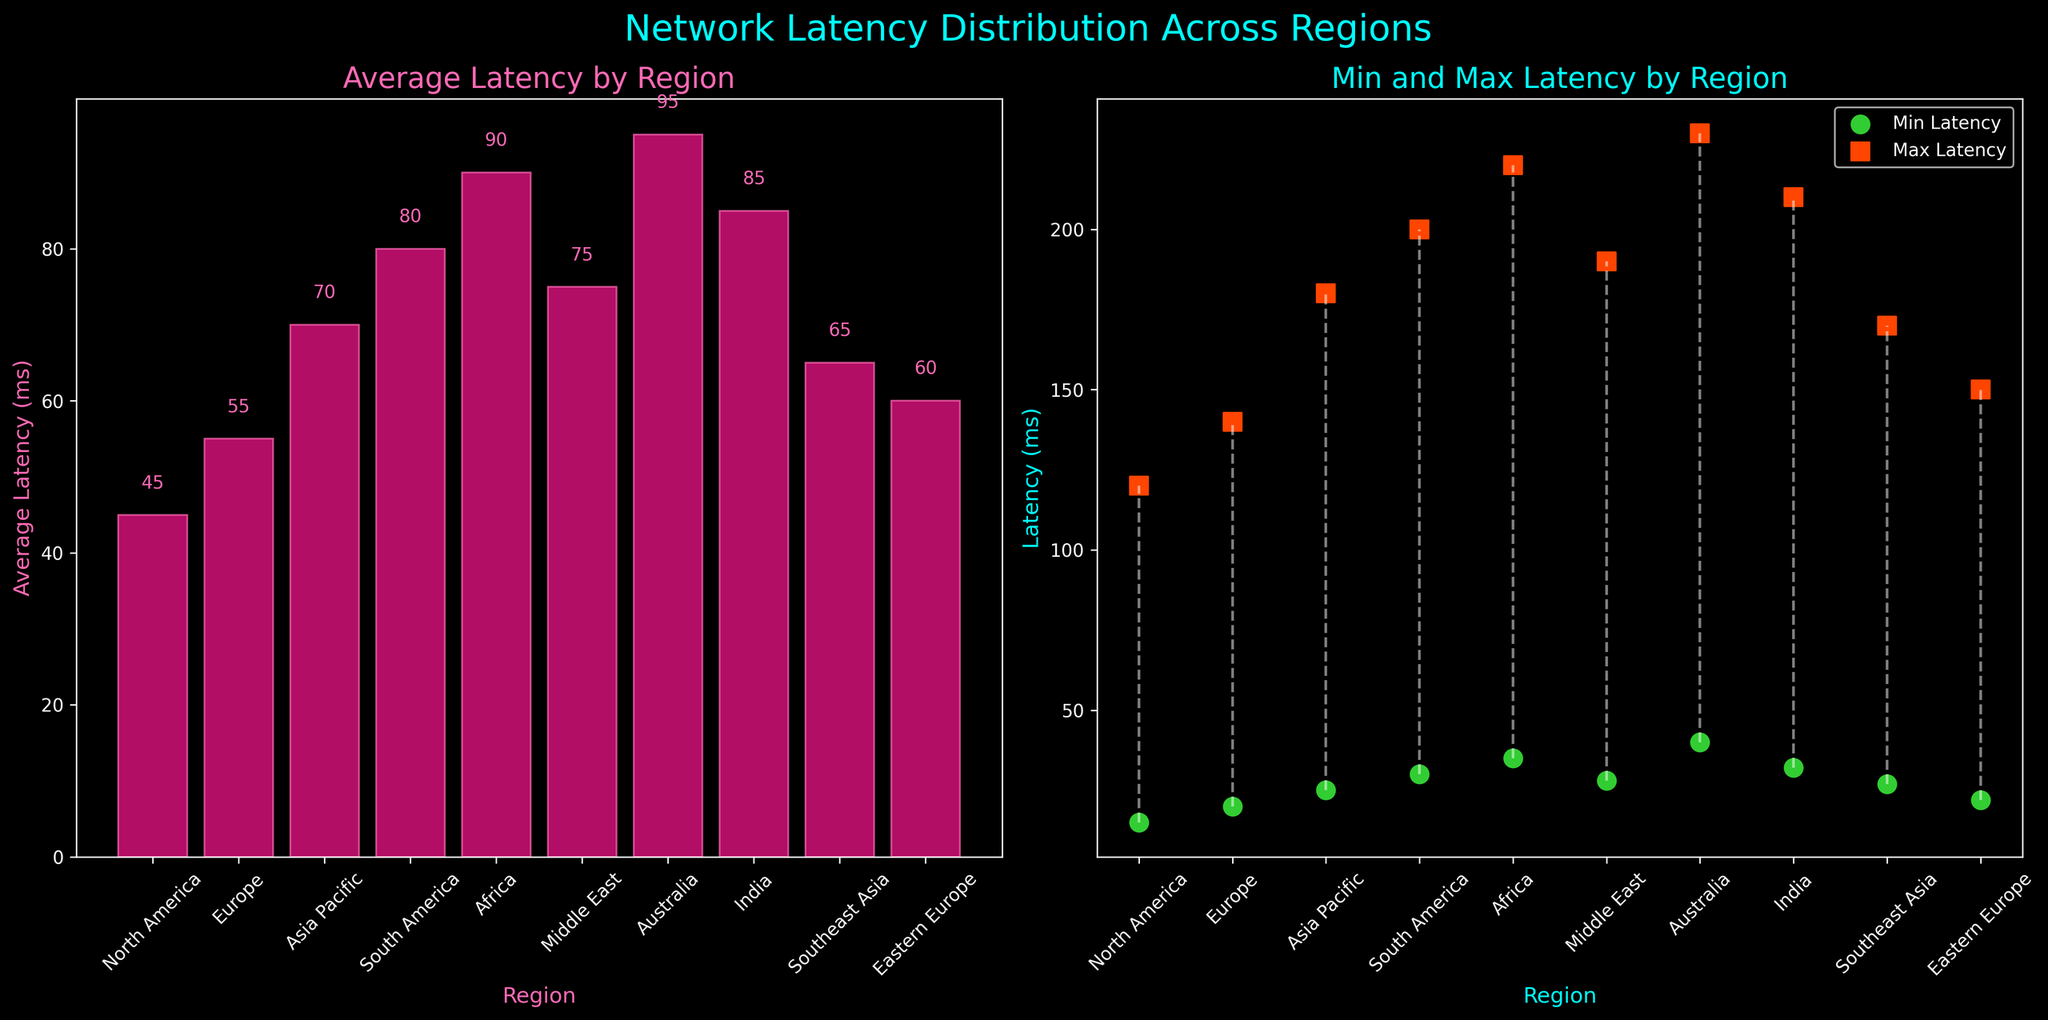What's the title of the left subplot? The left subplot title is at the top of the bar plot in the first subplot. It reads 'Average Latency by Region'.
Answer: Average Latency by Region How many regions are displayed in the plots? The x-axis on both subplots lists the regions. Counting the tick labels, there are 10 regions displayed in the plots.
Answer: 10 Which region has the highest average latency? The bar plot in the left subplot shows the average latencies. The tallest bar corresponds to Australia, making it the region with the highest average latency.
Answer: Australia What's the average latency value for Europe? Locate the Europe bar on the left subplot and read the value at the top of the bar, which is labeled as 55 ms.
Answer: 55 ms What's the difference between the minimum and maximum latency for South America? In the right subplot, South America's minimum latency is 30 ms, and its maximum latency is 200 ms. Subtracting these gives 200 ms - 30 ms = 170 ms.
Answer: 170 ms Which region has the smallest range of latencies? In the right subplot, look for the region with the smallest height difference between the minimum and maximum latency values. For Eastern Europe, the min latency is 22 ms, and the max latency is 150 ms, giving a range of 150 ms - 22 ms = 128 ms, which is the smallest among the regions.
Answer: Eastern Europe What colors are used for the min and max latencies? In the scatter plot on the right subplot, min latencies are indicated by green points, and max latencies are indicated by orange-red points.
Answer: Green and Orange-red Is the minimum latency in North America lower than that in Australia? In the right subplot, the minimum latency for North America is 15 ms, and for Australia, it is 40 ms. Comparing, 15 ms is lower than 40 ms.
Answer: Yes Which region has a higher maximum latency, India or the Middle East? In the right subplot, the maximum latency for India is 210 ms, and for the Middle East, it is 190 ms. India has a higher maximum latency.
Answer: India How many regions have an average latency above 80 ms? In the left subplot, the regions with bars higher than 80 ms are South America, Africa, Australia, and India. Counting these regions gives 4 regions.
Answer: 4 